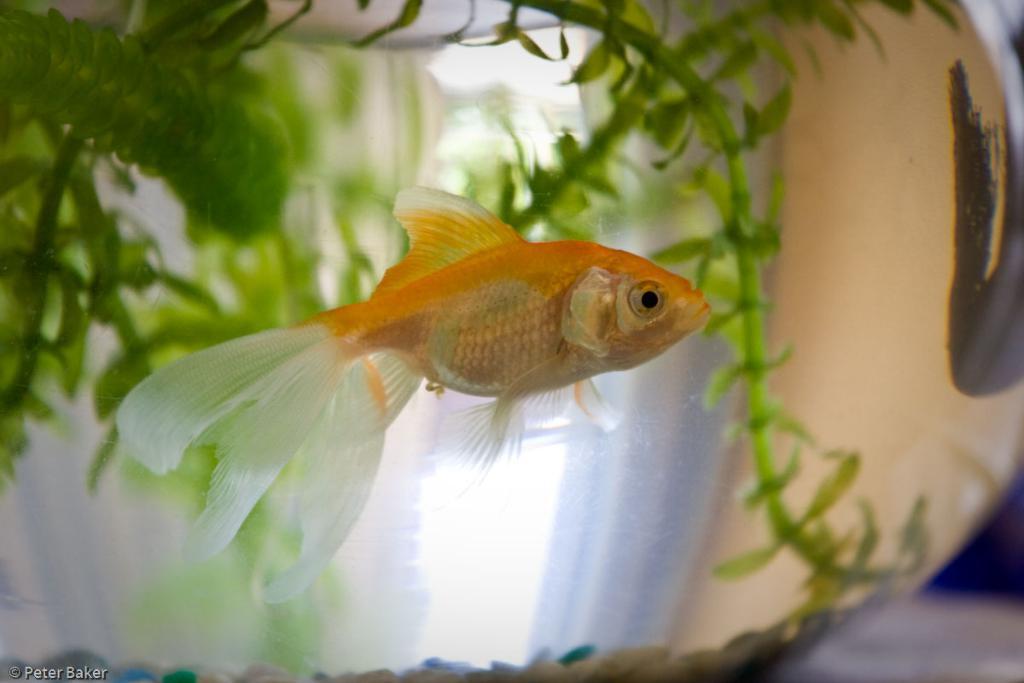Describe this image in one or two sentences. In a glass aquarium we can see a fish and the tiny plants. On the right side of the picture it seems like an another fish. In the bottom left corner of the picture we can see watermark. 